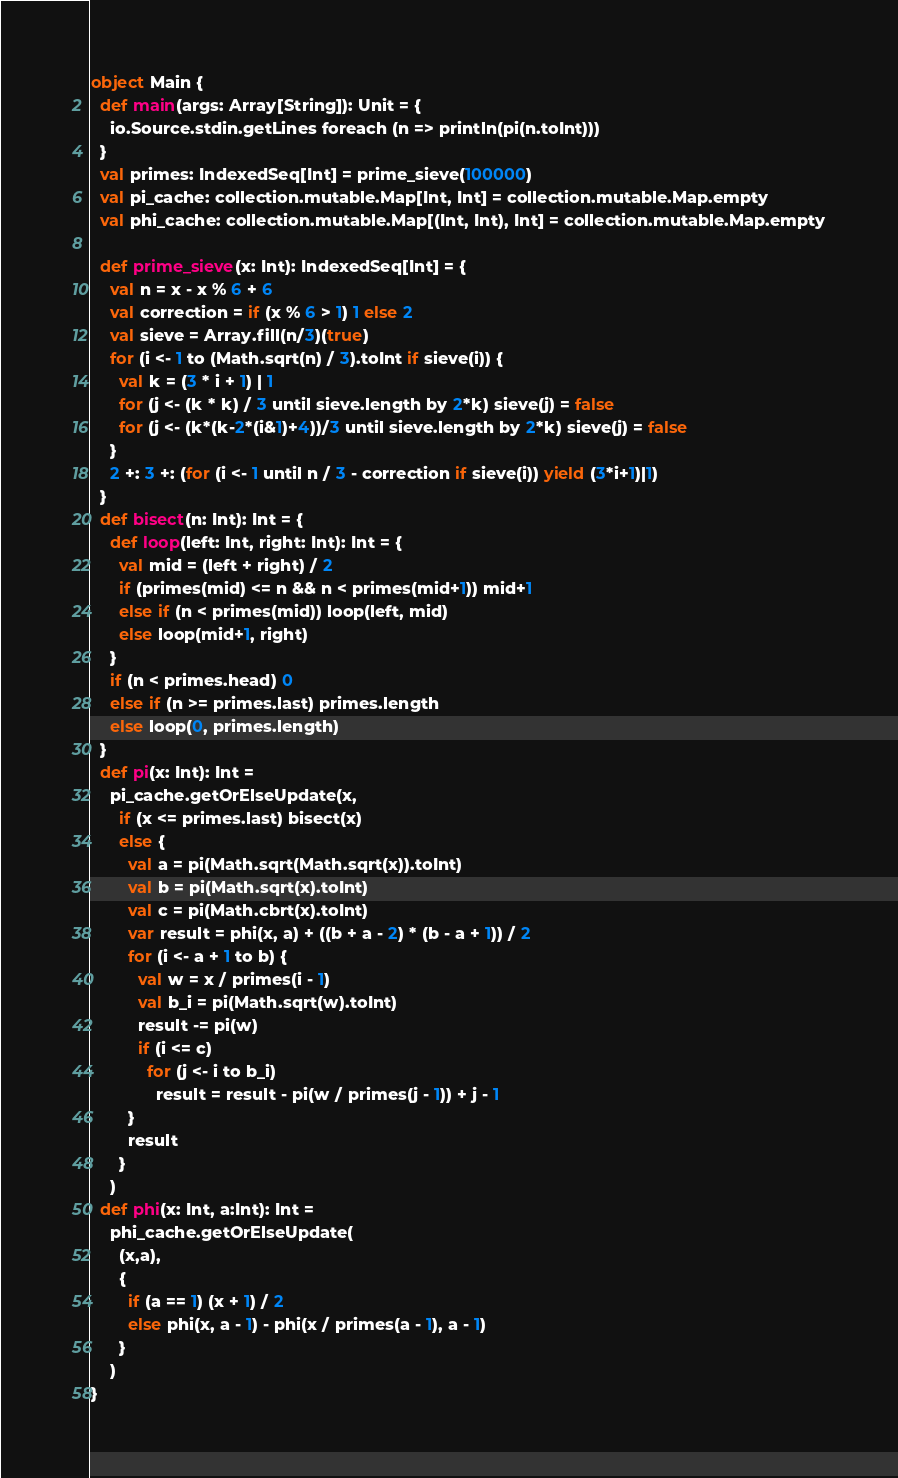Convert code to text. <code><loc_0><loc_0><loc_500><loc_500><_Scala_>object Main {
  def main(args: Array[String]): Unit = {
    io.Source.stdin.getLines foreach (n => println(pi(n.toInt)))
  }
  val primes: IndexedSeq[Int] = prime_sieve(100000)
  val pi_cache: collection.mutable.Map[Int, Int] = collection.mutable.Map.empty
  val phi_cache: collection.mutable.Map[(Int, Int), Int] = collection.mutable.Map.empty

  def prime_sieve(x: Int): IndexedSeq[Int] = {
    val n = x - x % 6 + 6
    val correction = if (x % 6 > 1) 1 else 2
    val sieve = Array.fill(n/3)(true)
    for (i <- 1 to (Math.sqrt(n) / 3).toInt if sieve(i)) {
      val k = (3 * i + 1) | 1
      for (j <- (k * k) / 3 until sieve.length by 2*k) sieve(j) = false
      for (j <- (k*(k-2*(i&1)+4))/3 until sieve.length by 2*k) sieve(j) = false
    }
    2 +: 3 +: (for (i <- 1 until n / 3 - correction if sieve(i)) yield (3*i+1)|1)
  }
  def bisect(n: Int): Int = {
    def loop(left: Int, right: Int): Int = {
      val mid = (left + right) / 2
      if (primes(mid) <= n && n < primes(mid+1)) mid+1
      else if (n < primes(mid)) loop(left, mid)
      else loop(mid+1, right)
    }
    if (n < primes.head) 0
    else if (n >= primes.last) primes.length
    else loop(0, primes.length)
  }
  def pi(x: Int): Int =
    pi_cache.getOrElseUpdate(x,
      if (x <= primes.last) bisect(x)
      else {
        val a = pi(Math.sqrt(Math.sqrt(x)).toInt)
        val b = pi(Math.sqrt(x).toInt)
        val c = pi(Math.cbrt(x).toInt)
        var result = phi(x, a) + ((b + a - 2) * (b - a + 1)) / 2
        for (i <- a + 1 to b) {
          val w = x / primes(i - 1)
          val b_i = pi(Math.sqrt(w).toInt)
          result -= pi(w)
          if (i <= c)
            for (j <- i to b_i)
              result = result - pi(w / primes(j - 1)) + j - 1
        }
        result
      }
    )
  def phi(x: Int, a:Int): Int =
    phi_cache.getOrElseUpdate(
      (x,a),
      {
        if (a == 1) (x + 1) / 2
        else phi(x, a - 1) - phi(x / primes(a - 1), a - 1)
      }
    )
}</code> 